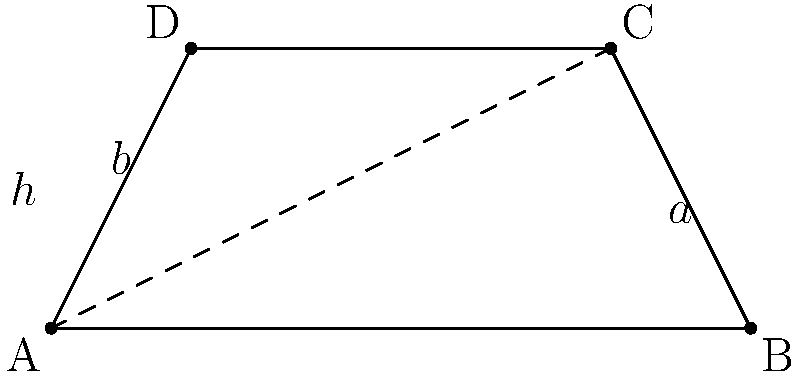In a trapezoid ABCD, the parallel sides measure $a = 10$ units and $b = 6$ units, and the height $h = 4$ units. Calculate the area of the trapezoid. To find the area of a trapezoid, we can use the formula:

$$\text{Area} = \frac{1}{2}(a + b)h$$

Where:
- $a$ and $b$ are the lengths of the parallel sides
- $h$ is the height of the trapezoid

Given:
- $a = 10$ units
- $b = 6$ units
- $h = 4$ units

Let's substitute these values into the formula:

$$\begin{align*}
\text{Area} &= \frac{1}{2}(a + b)h \\
&= \frac{1}{2}(10 + 6) \cdot 4 \\
&= \frac{1}{2}(16) \cdot 4 \\
&= 8 \cdot 4 \\
&= 32
\end{align*}$$

Therefore, the area of the trapezoid is 32 square units.
Answer: 32 square units 